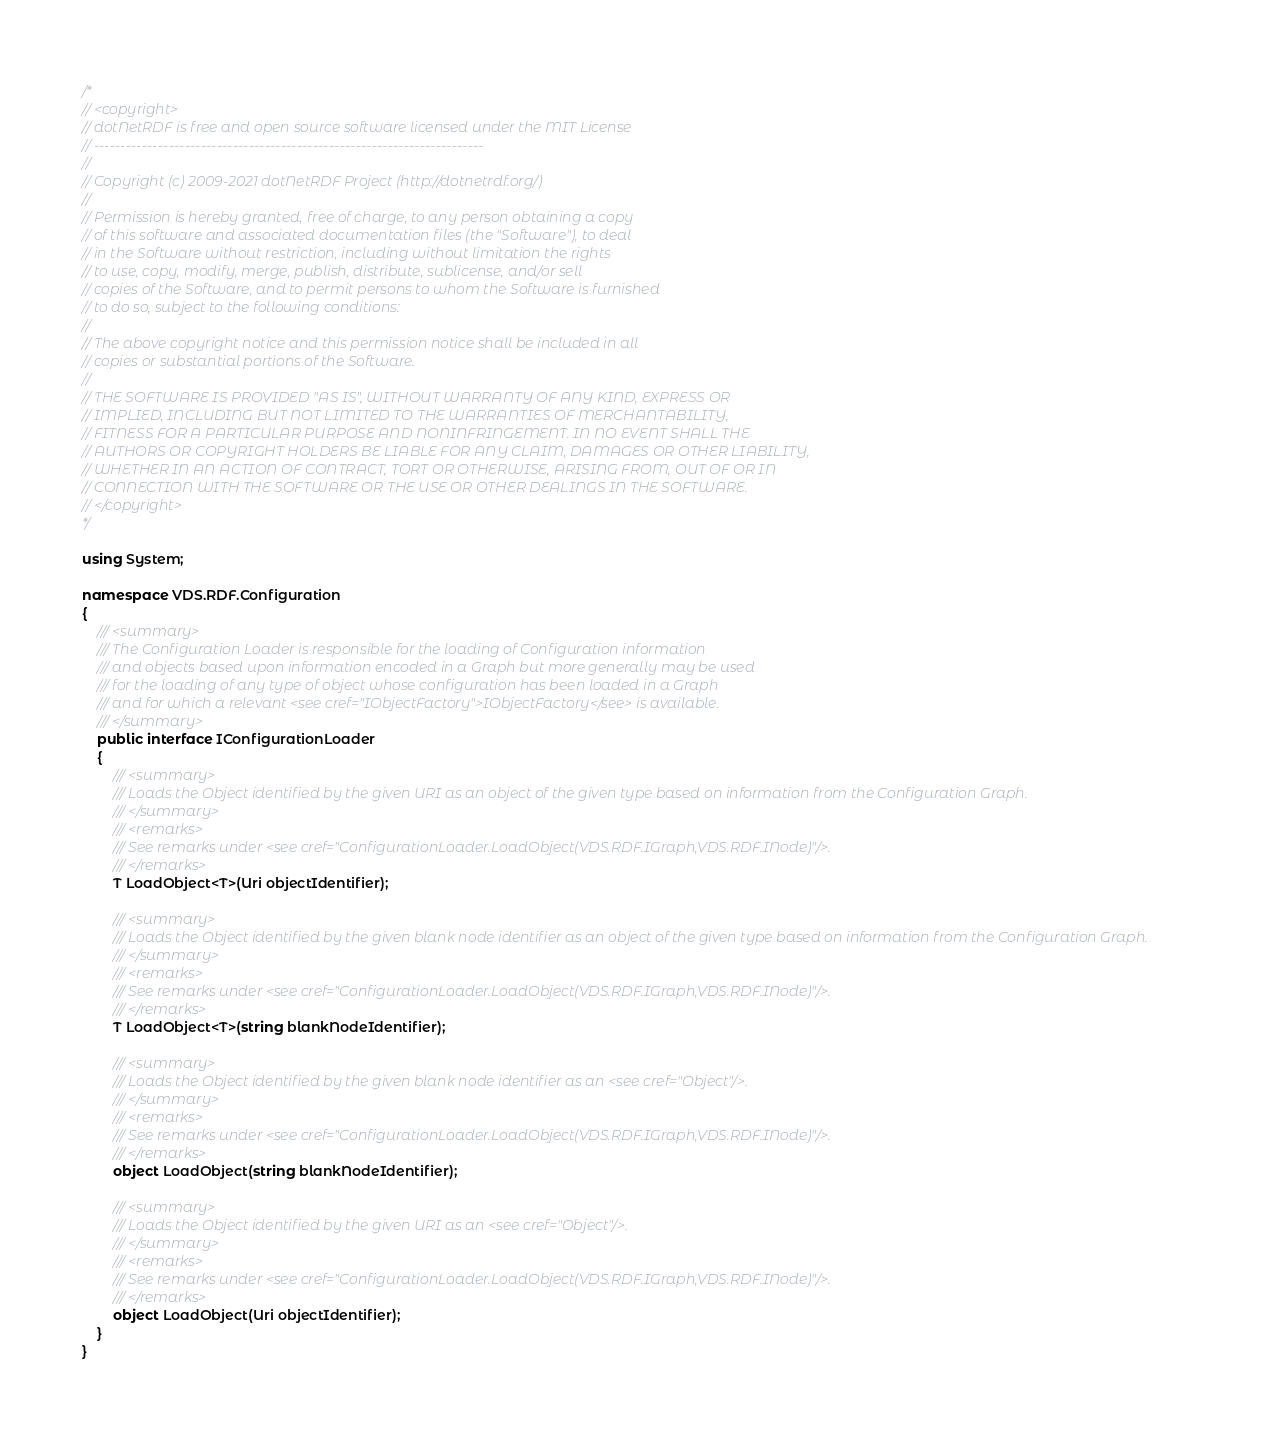Convert code to text. <code><loc_0><loc_0><loc_500><loc_500><_C#_>/*
// <copyright>
// dotNetRDF is free and open source software licensed under the MIT License
// -------------------------------------------------------------------------
// 
// Copyright (c) 2009-2021 dotNetRDF Project (http://dotnetrdf.org/)
// 
// Permission is hereby granted, free of charge, to any person obtaining a copy
// of this software and associated documentation files (the "Software"), to deal
// in the Software without restriction, including without limitation the rights
// to use, copy, modify, merge, publish, distribute, sublicense, and/or sell
// copies of the Software, and to permit persons to whom the Software is furnished
// to do so, subject to the following conditions:
// 
// The above copyright notice and this permission notice shall be included in all
// copies or substantial portions of the Software.
// 
// THE SOFTWARE IS PROVIDED "AS IS", WITHOUT WARRANTY OF ANY KIND, EXPRESS OR 
// IMPLIED, INCLUDING BUT NOT LIMITED TO THE WARRANTIES OF MERCHANTABILITY, 
// FITNESS FOR A PARTICULAR PURPOSE AND NONINFRINGEMENT. IN NO EVENT SHALL THE
// AUTHORS OR COPYRIGHT HOLDERS BE LIABLE FOR ANY CLAIM, DAMAGES OR OTHER LIABILITY,
// WHETHER IN AN ACTION OF CONTRACT, TORT OR OTHERWISE, ARISING FROM, OUT OF OR IN
// CONNECTION WITH THE SOFTWARE OR THE USE OR OTHER DEALINGS IN THE SOFTWARE.
// </copyright>
*/

using System;

namespace VDS.RDF.Configuration
{
    /// <summary>
    /// The Configuration Loader is responsible for the loading of Configuration information 
    /// and objects based upon information encoded in a Graph but more generally may be used 
    /// for the loading of any type of object whose configuration has been loaded in a Graph 
    /// and for which a relevant <see cref="IObjectFactory">IObjectFactory</see> is available.
    /// </summary>
    public interface IConfigurationLoader
    {
        /// <summary>
        /// Loads the Object identified by the given URI as an object of the given type based on information from the Configuration Graph.
        /// </summary>
        /// <remarks>
        /// See remarks under <see cref="ConfigurationLoader.LoadObject(VDS.RDF.IGraph,VDS.RDF.INode)"/>. 
        /// </remarks>
        T LoadObject<T>(Uri objectIdentifier);

        /// <summary>
        /// Loads the Object identified by the given blank node identifier as an object of the given type based on information from the Configuration Graph.
        /// </summary>
        /// <remarks>
        /// See remarks under <see cref="ConfigurationLoader.LoadObject(VDS.RDF.IGraph,VDS.RDF.INode)"/>. 
        /// </remarks>
        T LoadObject<T>(string blankNodeIdentifier);

        /// <summary>
        /// Loads the Object identified by the given blank node identifier as an <see cref="Object"/>.
        /// </summary>
        /// <remarks>
        /// See remarks under <see cref="ConfigurationLoader.LoadObject(VDS.RDF.IGraph,VDS.RDF.INode)"/>. 
        /// </remarks>
        object LoadObject(string blankNodeIdentifier);

        /// <summary>
        /// Loads the Object identified by the given URI as an <see cref="Object"/>.
        /// </summary>
        /// <remarks>
        /// See remarks under <see cref="ConfigurationLoader.LoadObject(VDS.RDF.IGraph,VDS.RDF.INode)"/>. 
        /// </remarks>
        object LoadObject(Uri objectIdentifier);
    }
}</code> 